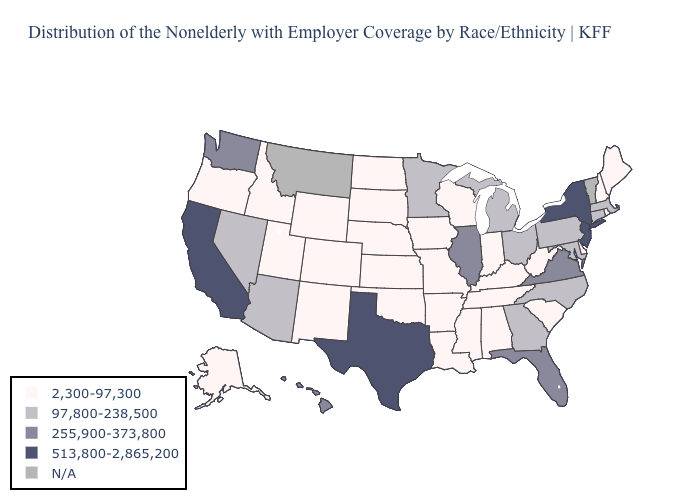Which states have the highest value in the USA?
Short answer required. California, New Jersey, New York, Texas. Which states have the lowest value in the USA?
Keep it brief. Alabama, Alaska, Arkansas, Colorado, Delaware, Idaho, Indiana, Iowa, Kansas, Kentucky, Louisiana, Maine, Mississippi, Missouri, Nebraska, New Hampshire, New Mexico, North Dakota, Oklahoma, Oregon, Rhode Island, South Carolina, South Dakota, Tennessee, Utah, West Virginia, Wisconsin, Wyoming. Among the states that border New Mexico , does Texas have the highest value?
Quick response, please. Yes. What is the lowest value in states that border Rhode Island?
Short answer required. 97,800-238,500. Does the first symbol in the legend represent the smallest category?
Quick response, please. Yes. Which states have the highest value in the USA?
Answer briefly. California, New Jersey, New York, Texas. Name the states that have a value in the range 97,800-238,500?
Short answer required. Arizona, Connecticut, Georgia, Maryland, Massachusetts, Michigan, Minnesota, Nevada, North Carolina, Ohio, Pennsylvania. Does Virginia have the lowest value in the South?
Short answer required. No. What is the lowest value in the USA?
Quick response, please. 2,300-97,300. What is the highest value in the USA?
Short answer required. 513,800-2,865,200. Does Tennessee have the lowest value in the South?
Quick response, please. Yes. Does Texas have the highest value in the South?
Short answer required. Yes. Does the map have missing data?
Write a very short answer. Yes. 